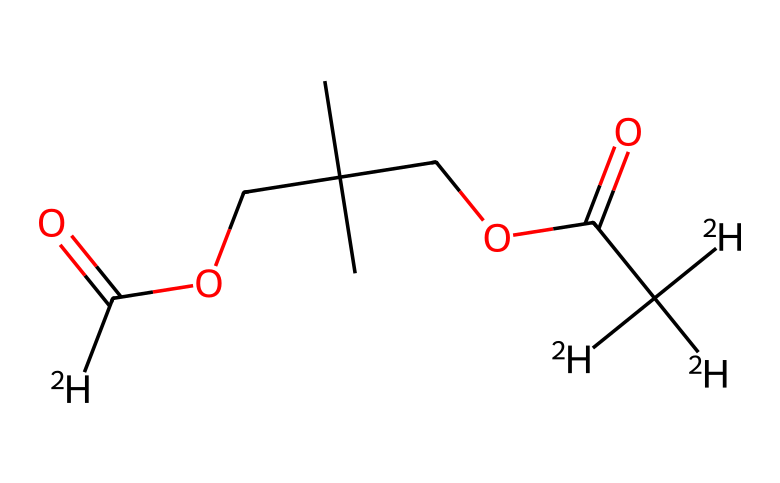How many deuterium atoms are present in this compound? The structure contains [2H] symbols, which represent deuterium. Counting these within the provided SMILES indicates there are four occurrences of [2H].
Answer: four What type of functional groups are represented in this chemical? Looking at the structure, the SMILES shows carbonyl groups (C(=O)) and alkoxy groups (OCC). These indicate the presence of carboxylic acid and ester functionalities.
Answer: carboxylic acid and ester What is the total number of carbon atoms in this compound? By analyzing the SMILES, each C is counted, giving us a total of twelve carbon atoms in the entire structure.
Answer: twelve What role do deuterium-labeled compounds play in outdoor coatings? Deuterium-labeled compounds can enhance stability and tracking within the coatings, which is useful for understanding their degradation over time.
Answer: stability and tracking What is the significance of using deuterium in this compound? Deuterium enhances the thermal and chemical stability of the compound, making it more suitable for weatherproof applications.
Answer: thermal and chemical stability How many oxygen atoms can be identified in the structure? By analyzing the SMILES representation for 'O' characters, we find there are three oxygen atoms present.
Answer: three Which part of the molecule contributes to its water resistance? The hydrophobic alkyl chains in the structure help reduce the interaction with water, contributing to its overall water resistance.
Answer: hydrophobic alkyl chains 